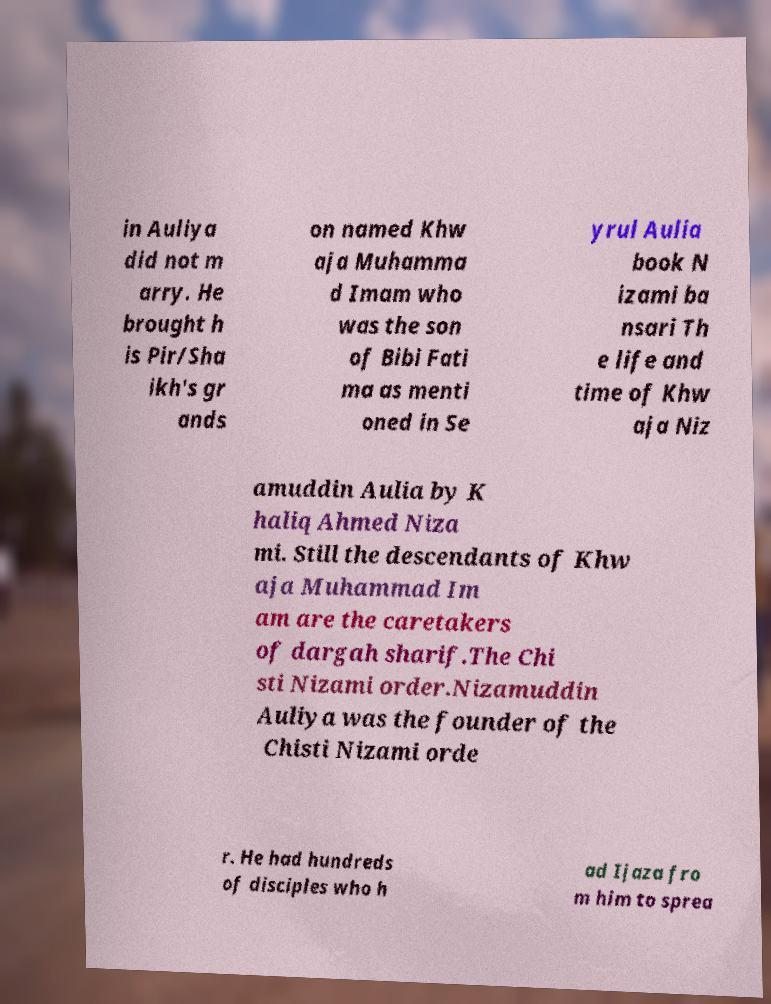Could you extract and type out the text from this image? in Auliya did not m arry. He brought h is Pir/Sha ikh's gr ands on named Khw aja Muhamma d Imam who was the son of Bibi Fati ma as menti oned in Se yrul Aulia book N izami ba nsari Th e life and time of Khw aja Niz amuddin Aulia by K haliq Ahmed Niza mi. Still the descendants of Khw aja Muhammad Im am are the caretakers of dargah sharif.The Chi sti Nizami order.Nizamuddin Auliya was the founder of the Chisti Nizami orde r. He had hundreds of disciples who h ad Ijaza fro m him to sprea 